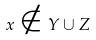<formula> <loc_0><loc_0><loc_500><loc_500>x \notin Y \cup Z</formula> 